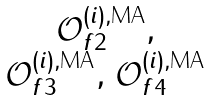Convert formula to latex. <formula><loc_0><loc_0><loc_500><loc_500>\begin{matrix} \mathcal { O } ^ { ( i ) , \text {MA} } _ { f 2 } , \\ \mathcal { O } ^ { ( i ) , \text {MA} } _ { f 3 } , \, \mathcal { O } ^ { ( i ) , \text {MA} } _ { f 4 } \end{matrix}</formula> 